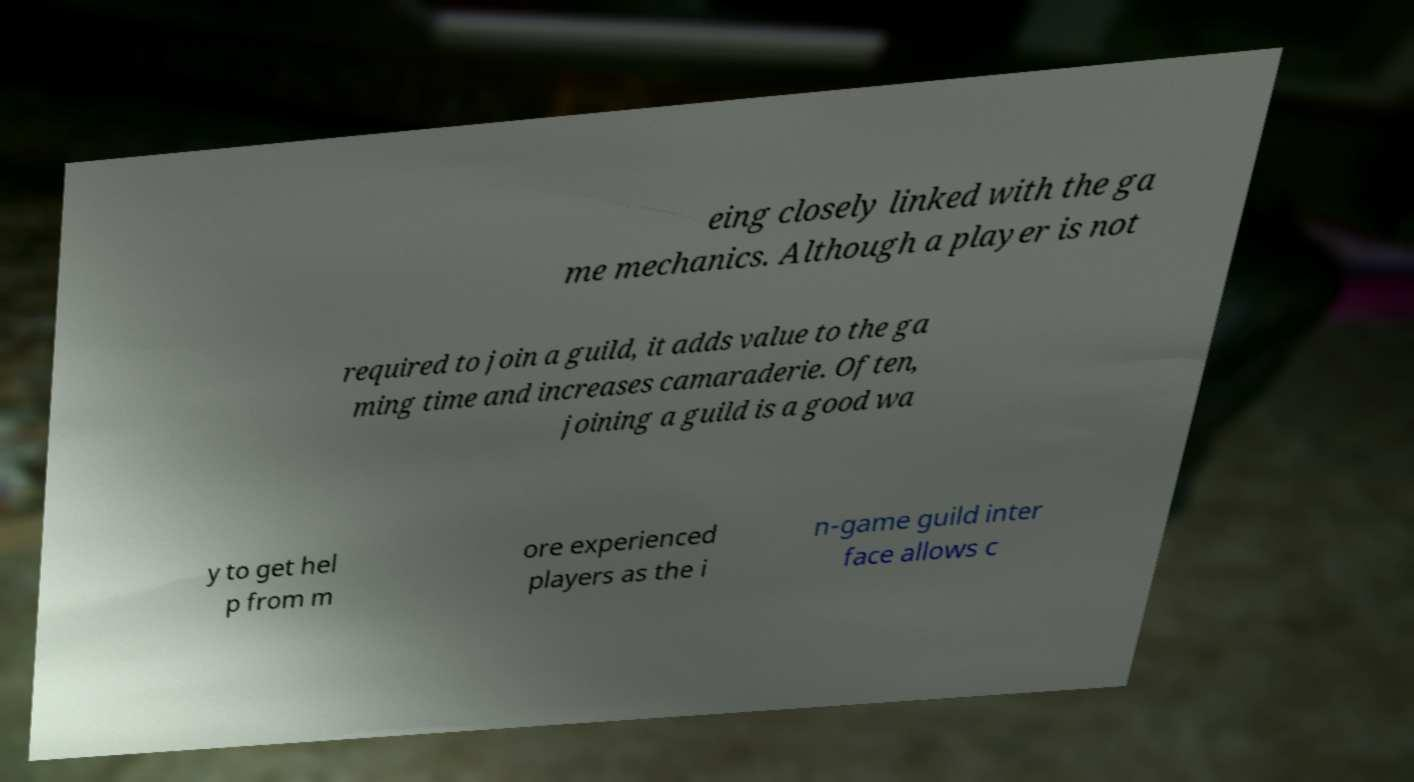Could you extract and type out the text from this image? eing closely linked with the ga me mechanics. Although a player is not required to join a guild, it adds value to the ga ming time and increases camaraderie. Often, joining a guild is a good wa y to get hel p from m ore experienced players as the i n-game guild inter face allows c 